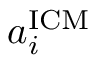Convert formula to latex. <formula><loc_0><loc_0><loc_500><loc_500>a _ { i } ^ { I C M }</formula> 